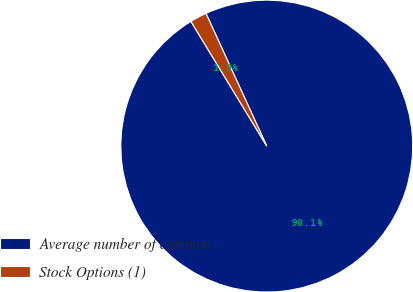Convert chart to OTSL. <chart><loc_0><loc_0><loc_500><loc_500><pie_chart><fcel>Average number of common<fcel>Stock Options (1)<nl><fcel>98.14%<fcel>1.86%<nl></chart> 